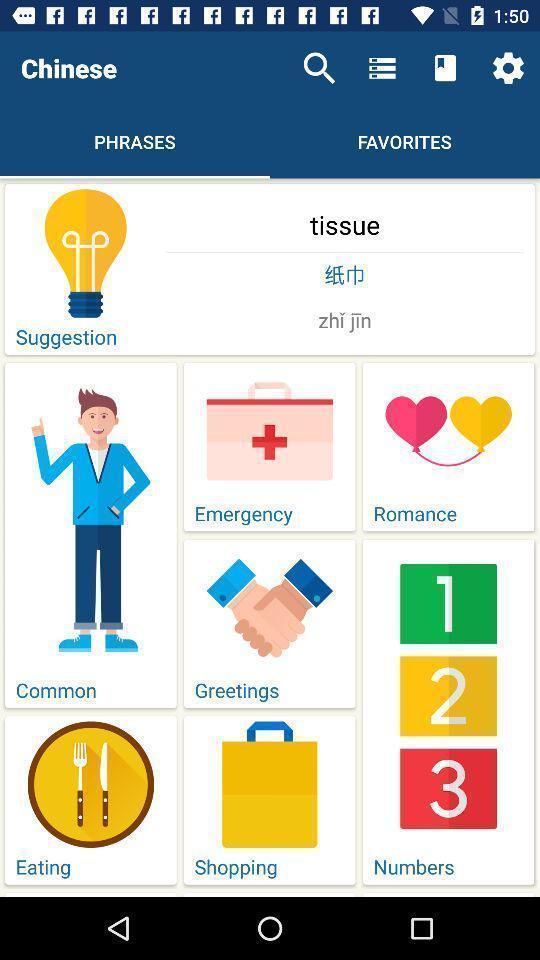Summarize the main components in this picture. Screen display shows about language learning app. 